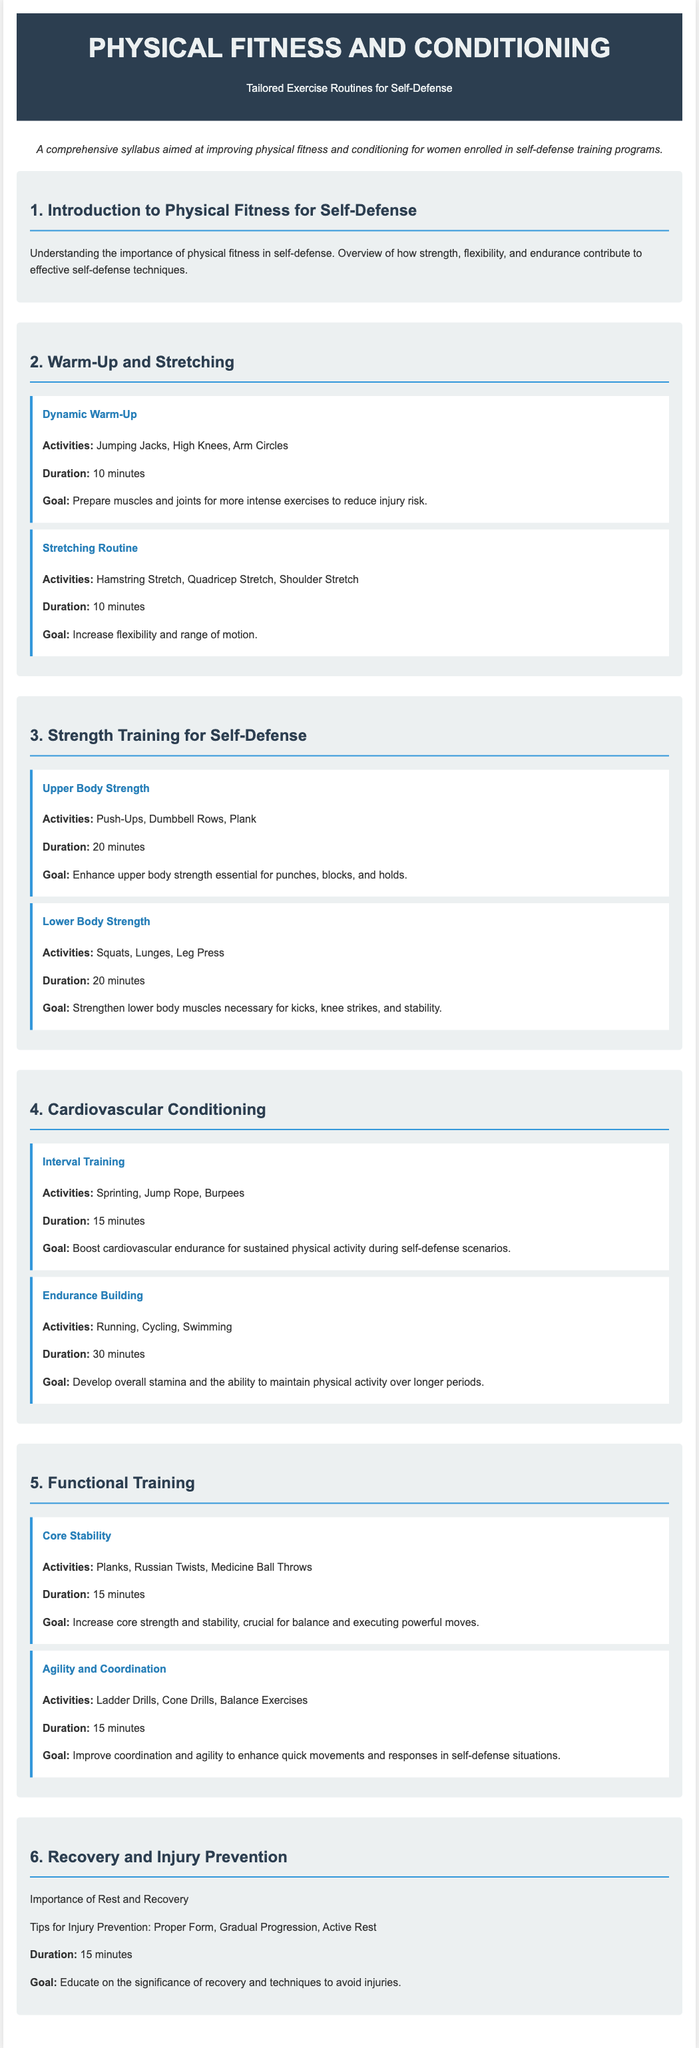What is the main goal of the syllabus? The main goal of the syllabus is to provide a comprehensive approach to improving physical fitness for women enrolled in self-defense training programs.
Answer: Improving physical fitness What activities are included in the dynamic warm-up? The document lists specific activities that are part of the dynamic warm-up.
Answer: Jumping Jacks, High Knees, Arm Circles How long should the stretching routine last? The duration specified for the stretching routine is noted in the document.
Answer: 10 minutes What is the focus of the core stability module? This module aims to increase core strength and stability, which is clearly stated in the document.
Answer: Increase core strength and stability What are the activities listed for interval training? The specific activities outlined in the document for interval training are requested.
Answer: Sprinting, Jump Rope, Burpees How many minutes are allocated for lower body strength training? The duration for lower body strength training is indicated in the syllabus.
Answer: 20 minutes What is the goal of endurance building? The document describes the objective of endurance building activities in one phrase.
Answer: Develop overall stamina What tips are provided for injury prevention? The document mentions several specific tips related to injury prevention.
Answer: Proper Form, Gradual Progression, Active Rest What section explains the importance of recovery? The section dedicated to discussing recovery and injury prevention is referred to.
Answer: Recovery and Injury Prevention 